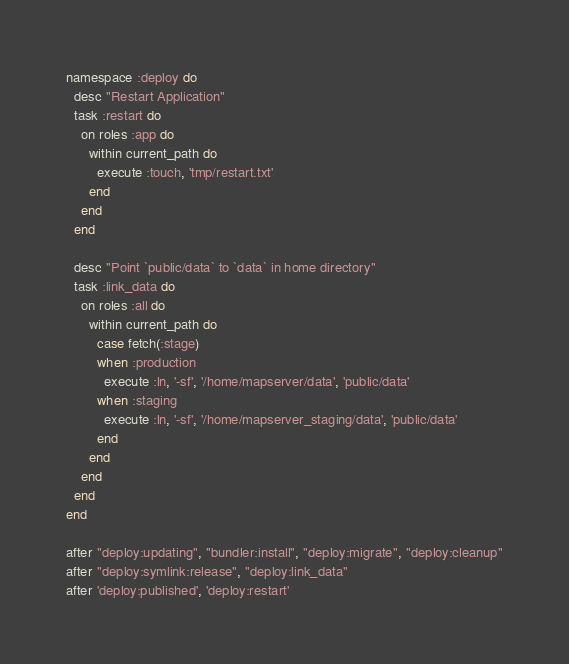Convert code to text. <code><loc_0><loc_0><loc_500><loc_500><_Ruby_>namespace :deploy do
  desc "Restart Application"
  task :restart do
    on roles :app do
      within current_path do
        execute :touch, 'tmp/restart.txt'
      end
    end
  end

  desc "Point `public/data` to `data` in home directory"
  task :link_data do
  	on roles :all do
      within current_path do
        case fetch(:stage)
        when :production
          execute :ln, '-sf', '/home/mapserver/data', 'public/data'
        when :staging
          execute :ln, '-sf', '/home/mapserver_staging/data', 'public/data'
        end
      end
    end
  end
end

after "deploy:updating", "bundler:install", "deploy:migrate", "deploy:cleanup"
after "deploy:symlink:release", "deploy:link_data"
after 'deploy:published', 'deploy:restart'
</code> 